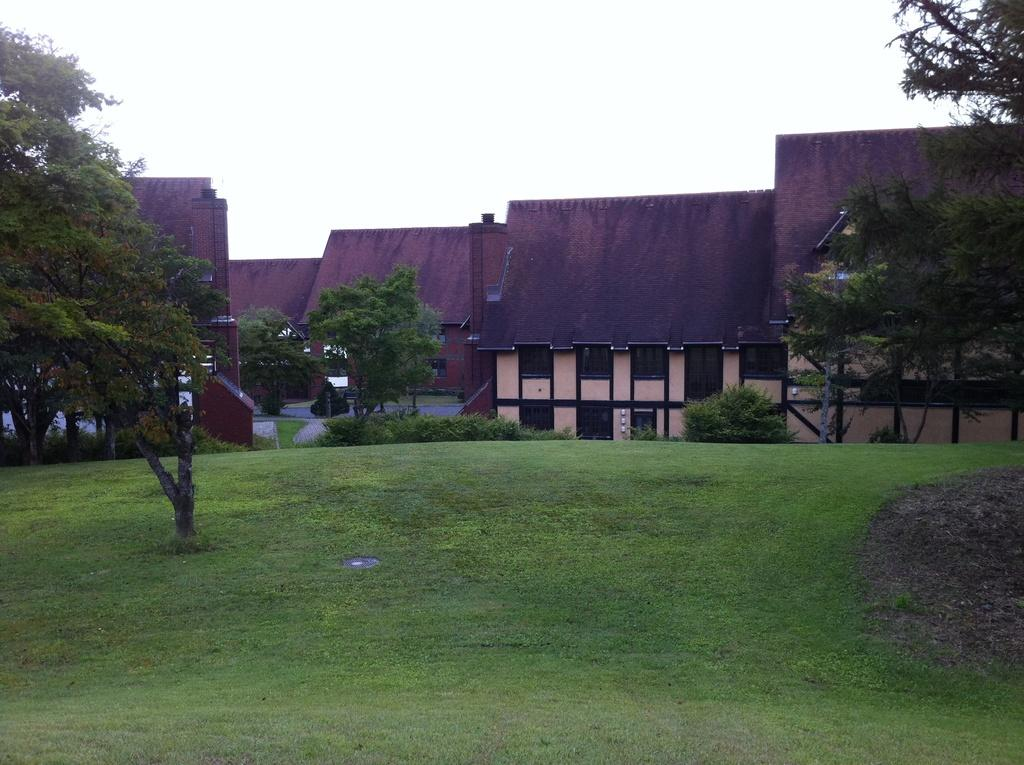What type of structures can be seen in the image? There are many buildings in the image. What is the purpose of the road in the image? The road in the image is likely for transportation. What feature do the buildings have in common? The buildings have windows. What type of vegetation is present in the image? There is grass and trees in the image. What is the color of the sky in the image? The sky is white in the image. How can you sort the buildings in the image by their quietness? The image does not provide information about the quietness of the buildings, so it is not possible to sort them based on that characteristic. 